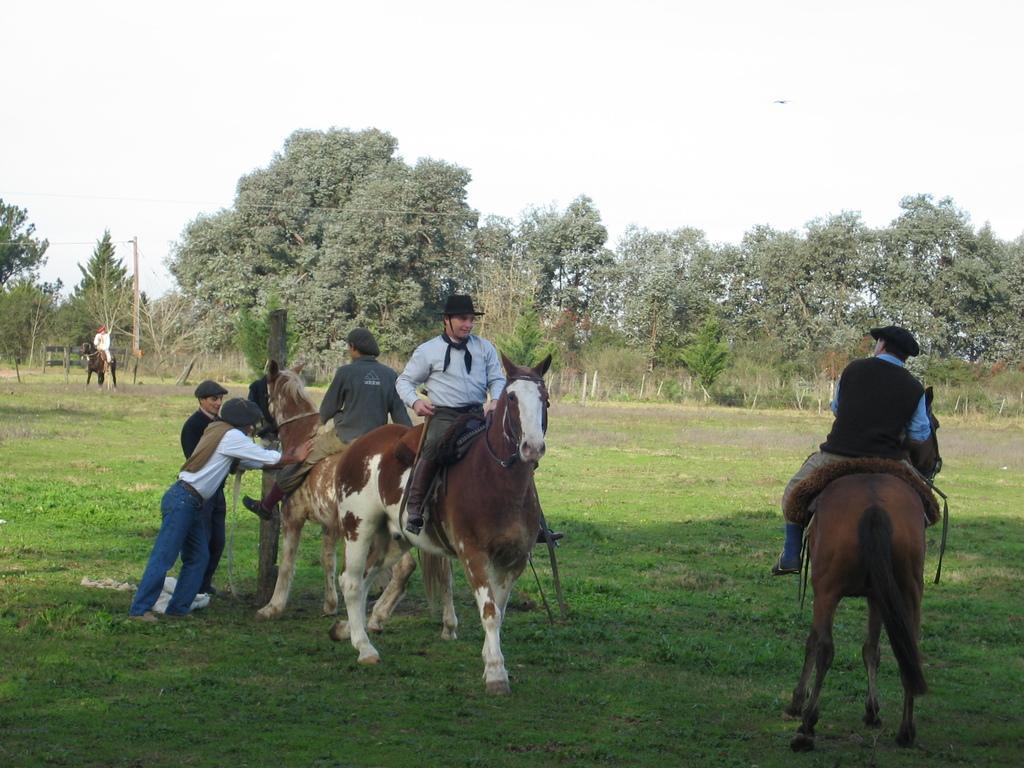Describe this image in one or two sentences. In this picture there are three men who are sitting on a horse. Two men are standing to the left side. There is a man sitting on a horse in the background. 